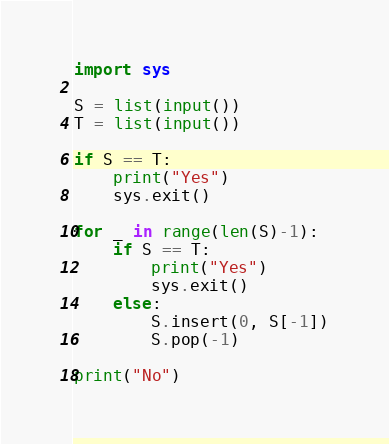Convert code to text. <code><loc_0><loc_0><loc_500><loc_500><_Python_>import sys

S = list(input())
T = list(input())

if S == T:
    print("Yes")
    sys.exit()

for _ in range(len(S)-1):
    if S == T:
        print("Yes")
        sys.exit()
    else:
        S.insert(0, S[-1])
        S.pop(-1)

print("No")</code> 